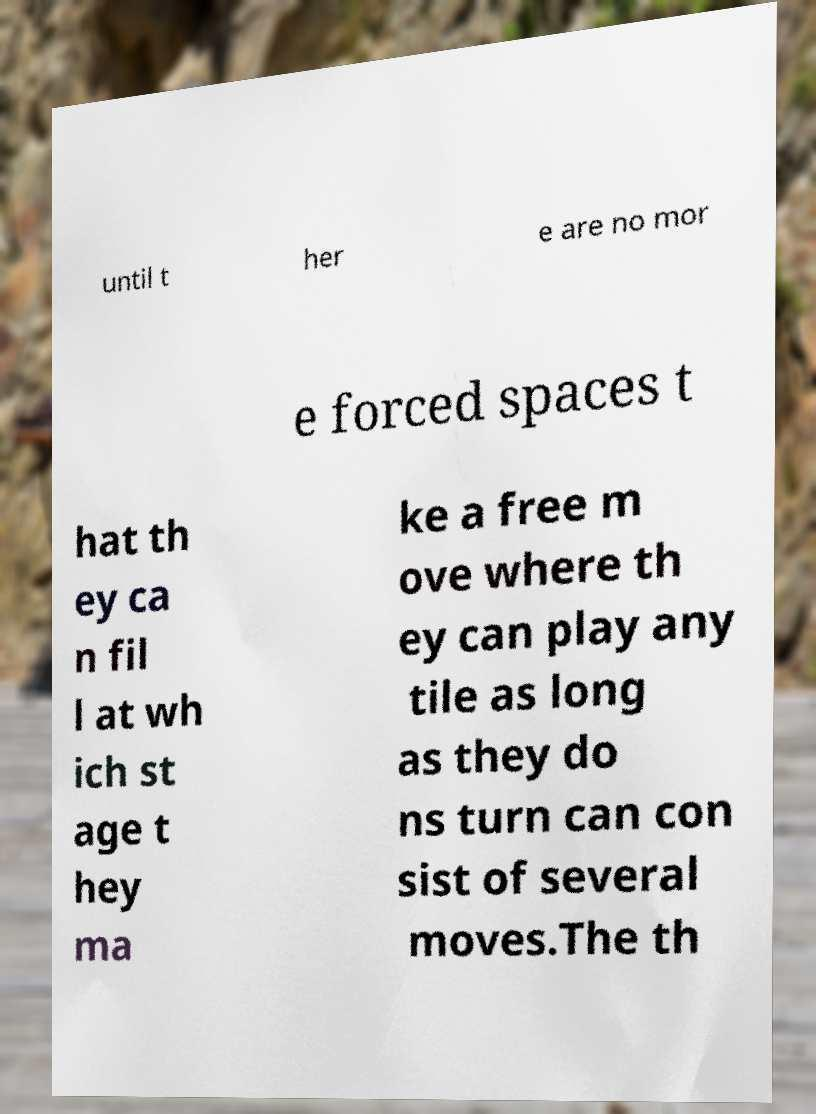Please read and relay the text visible in this image. What does it say? until t her e are no mor e forced spaces t hat th ey ca n fil l at wh ich st age t hey ma ke a free m ove where th ey can play any tile as long as they do ns turn can con sist of several moves.The th 